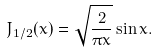Convert formula to latex. <formula><loc_0><loc_0><loc_500><loc_500>J _ { 1 / 2 } ( x ) = \sqrt { \frac { 2 } { \pi x } } \sin x .</formula> 